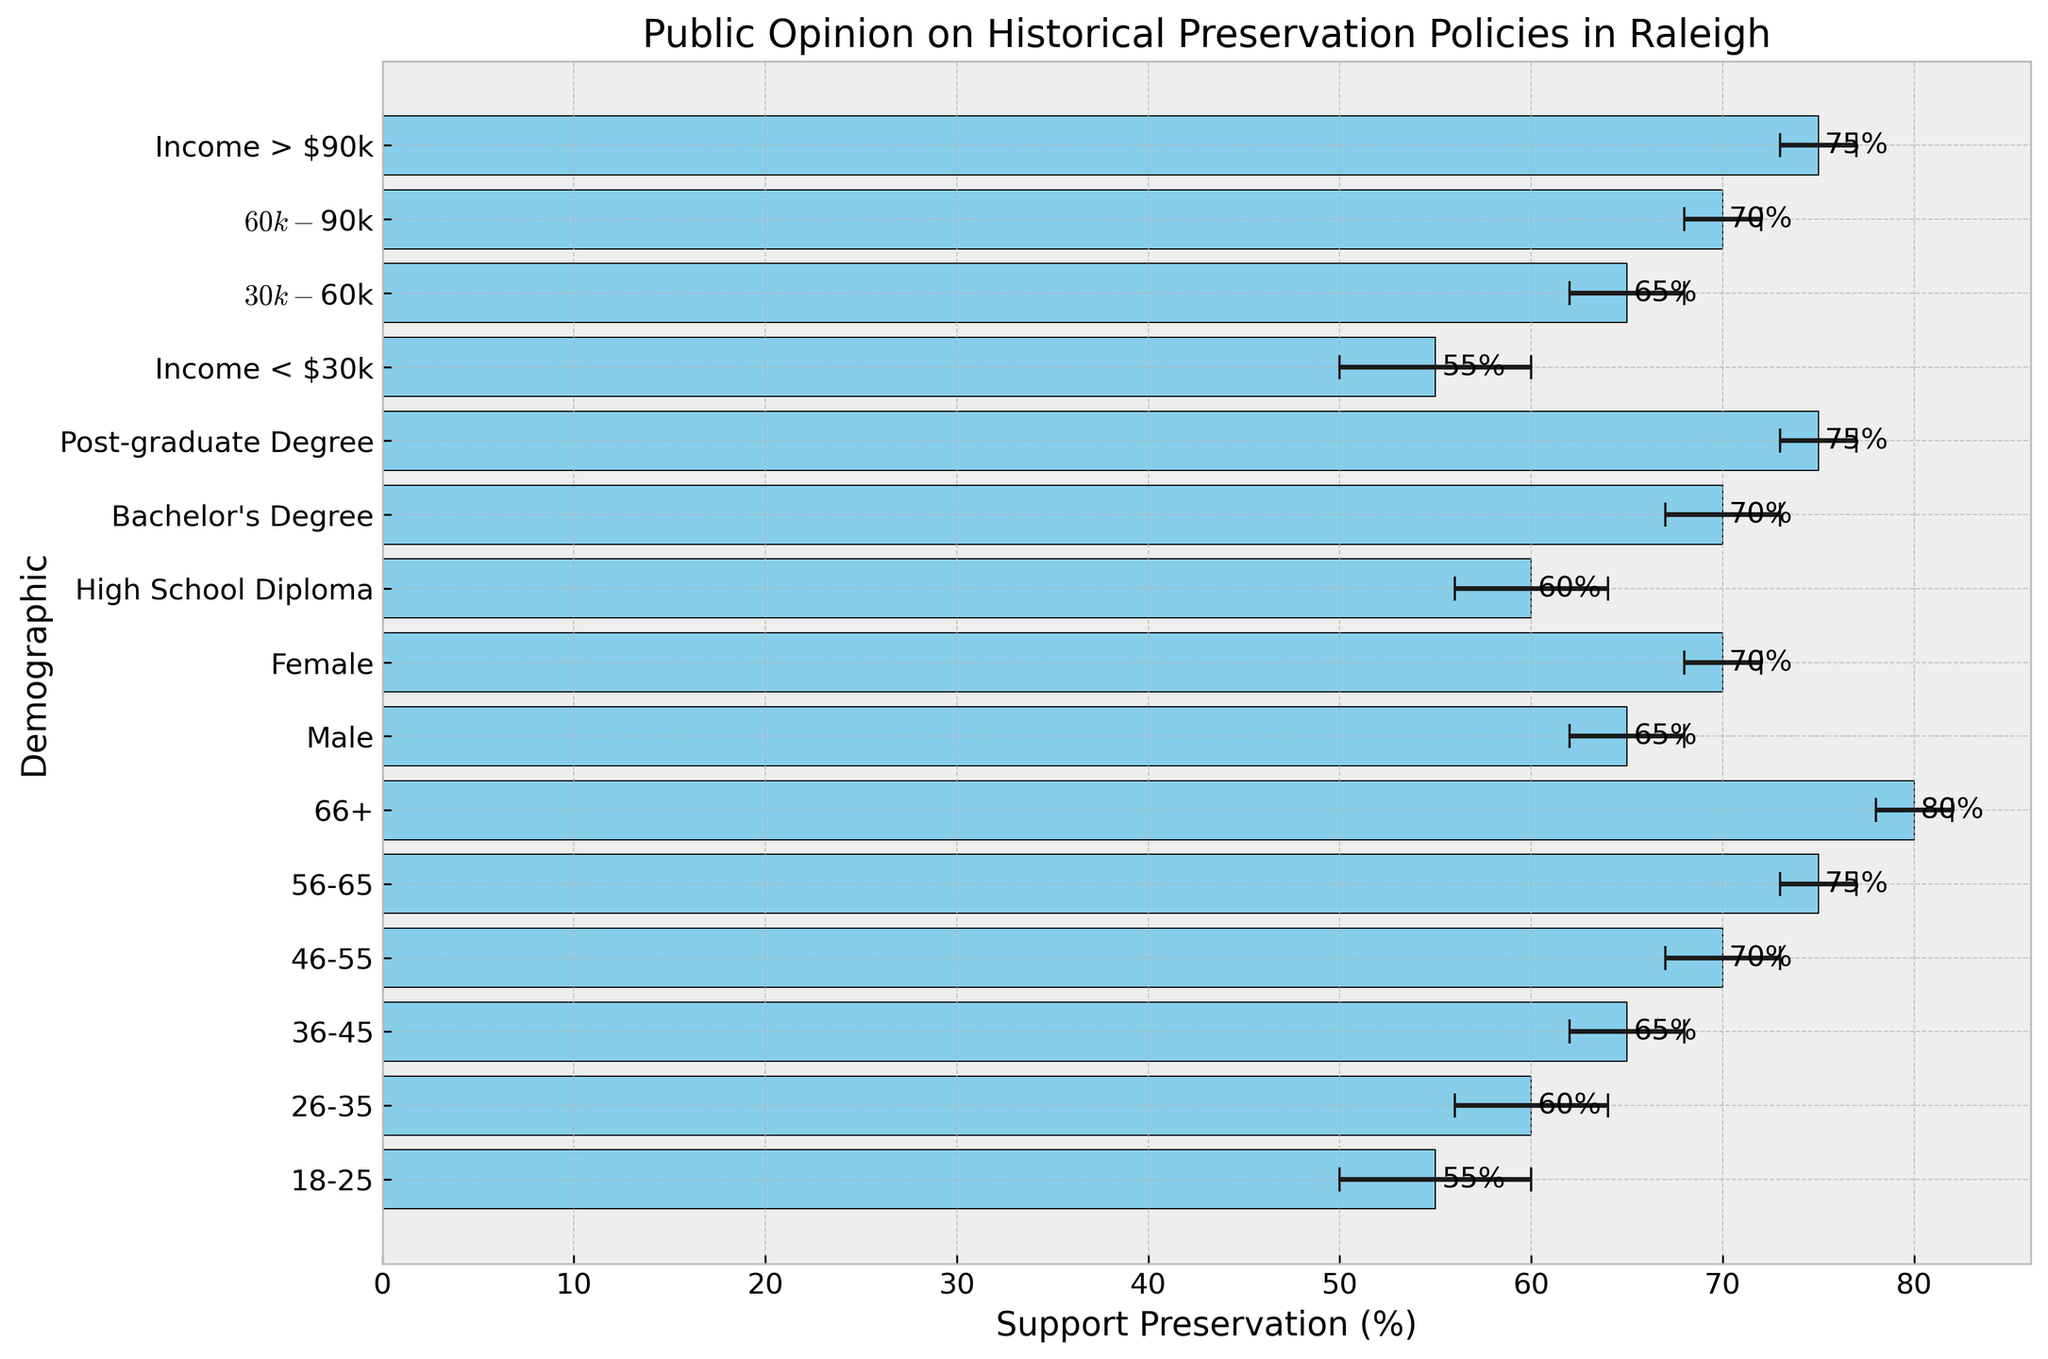What is the average support for preservation across all age groups? To find the average, add the support percentages for all age groups (55% + 60% + 65% + 70% + 75% + 80%) and divide by the number of age groups (6). The calculation is (55 + 60 + 65 + 70 + 75 + 80) / 6.
Answer: 67.5% Which demographic has the highest support for historical preservation? Look for the demographic category with the highest bar in the figure, which represents the highest support percentage.
Answer: 66+ Compare the support for historical preservation between males and females. Which group is more supportive, and by how much? Check the bar lengths for 'Male' and 'Female'. The support for males is 65%, and for females, it's 70%. The difference is 70% - 65%.
Answer: Females, by 5% What is the total error margin for the demographics with Bachelor's Degree and Post-graduate Degree? Add the error margins for both categories: 3% (Bachelor's Degree) + 2% (Post-graduate Degree).
Answer: 5% Which income group has the lowest support for historical preservation? Identify the income group with the shortest bar. The support percentages are: < $30k (55%), $30k-$60k (65%), $60k-$90k (70%), > $90k (75%). The lowest support is from < $30k.
Answer: Income < $30k What is the range of support percentages for the demographic groups defined by education level? To find the range, subtract the smallest support percentage (High School Diploma - 60%) from the largest (Post-graduate Degree - 75%). The calculation is 75% - 60%.
Answer: 15% If the error margins for all age groups were doubled, what would be the new error margin for the 26-35 age group? The current error margin for the 26-35 age group is 4%. Doubling it gives 4% * 2.
Answer: 8% How many demographic categories have a support percentage greater than 65%? Count the number of bars with values greater than 65%. These include: 36-45 (65%), 46-55 (70%), 56-65 (75%), 66+ (80%), Female (70%), Bachelor's Degree (70%), Post-graduate Degree (75%), $60k-$90k (70%), and > $90k (75%). In total, 9 categories.
Answer: 9 Which age group shows the smallest error margin, and what is its support percentage? Look for the age group with the smallest error margin which is the 66+ group with an error margin of 2%. The support percentage for this group is 80%.
Answer: 66+, 80% 